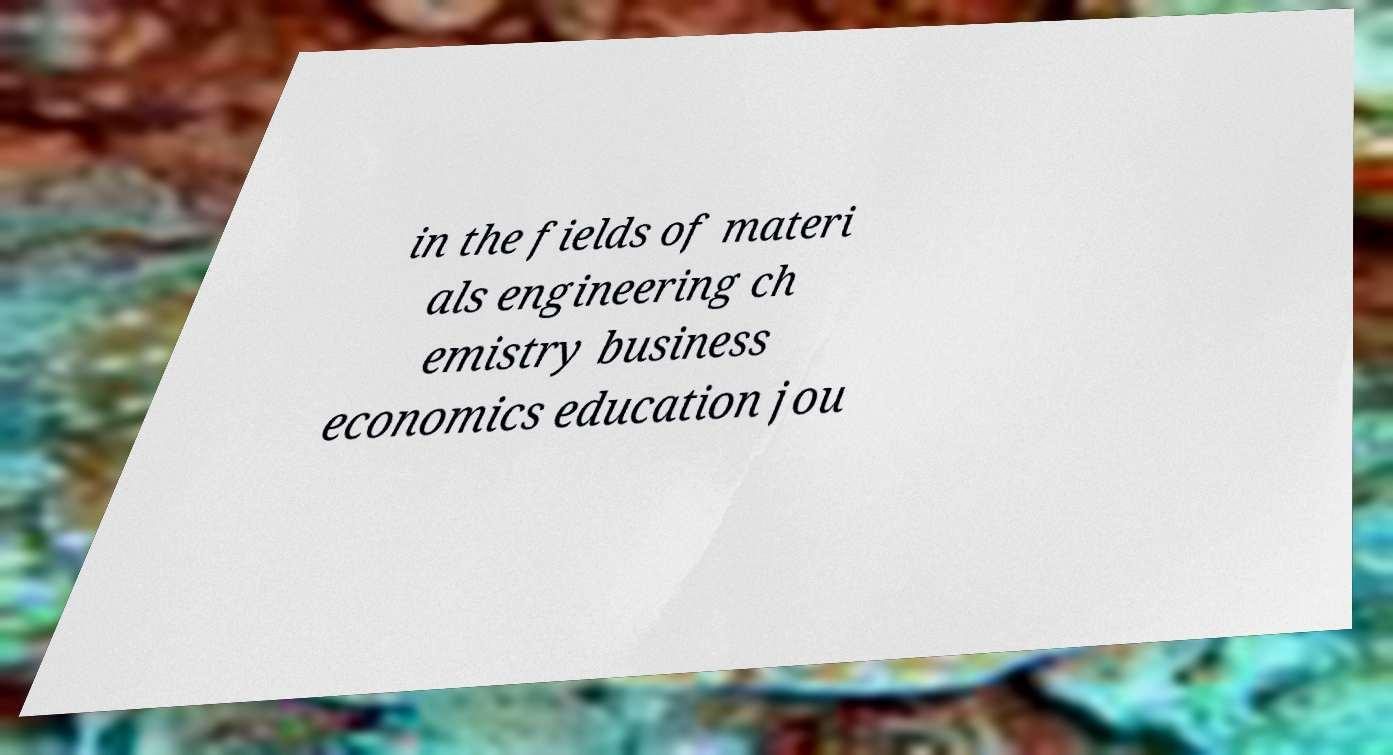Can you accurately transcribe the text from the provided image for me? in the fields of materi als engineering ch emistry business economics education jou 